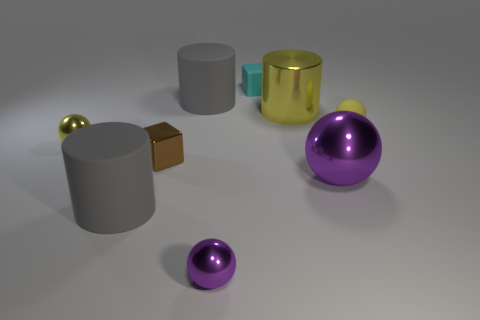What color is the metallic thing behind the small shiny sphere that is on the left side of the tiny brown metallic cube?
Provide a short and direct response. Yellow. There is a matte object that is both right of the tiny purple metal ball and behind the tiny yellow matte sphere; what size is it?
Offer a very short reply. Small. What number of other things are there of the same shape as the big purple shiny object?
Keep it short and to the point. 3. There is a large yellow thing; is its shape the same as the small yellow thing that is left of the tiny purple sphere?
Ensure brevity in your answer.  No. How many small purple balls are to the right of the small purple metallic object?
Make the answer very short. 0. Are there any other things that have the same material as the large yellow thing?
Keep it short and to the point. Yes. Does the gray object in front of the metal block have the same shape as the brown thing?
Provide a short and direct response. No. There is a small cube that is in front of the tiny cyan cube; what color is it?
Offer a terse response. Brown. What is the shape of the tiny yellow object that is the same material as the brown block?
Offer a very short reply. Sphere. Are there any other things of the same color as the metal cylinder?
Offer a terse response. Yes. 